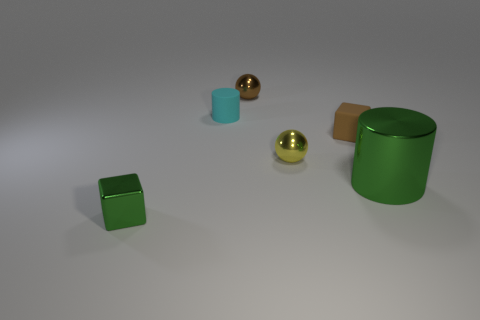Add 1 small green shiny things. How many objects exist? 7 Subtract all yellow balls. How many balls are left? 1 Subtract all cylinders. How many objects are left? 4 Subtract all red balls. Subtract all cyan blocks. How many balls are left? 2 Subtract all purple cylinders. How many brown balls are left? 1 Subtract all shiny blocks. Subtract all small metal cubes. How many objects are left? 4 Add 6 small matte cylinders. How many small matte cylinders are left? 7 Add 5 cyan rubber blocks. How many cyan rubber blocks exist? 5 Subtract 0 brown cylinders. How many objects are left? 6 Subtract 1 cylinders. How many cylinders are left? 1 